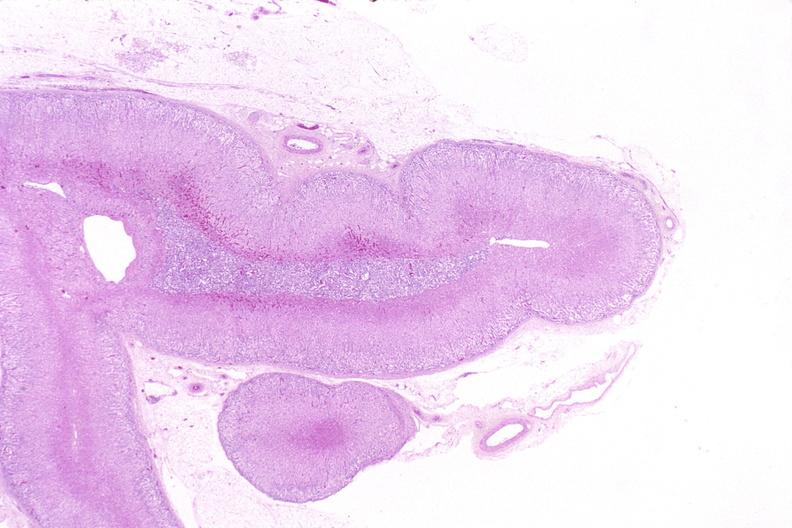does nodular tumor show adrenal gland, normal histology?
Answer the question using a single word or phrase. No 